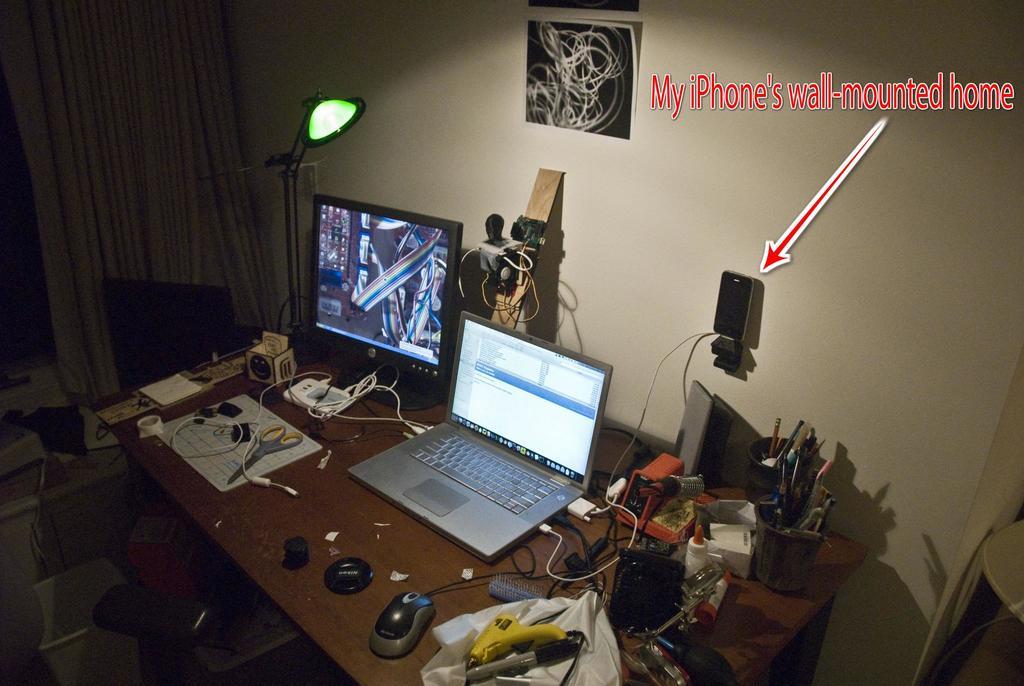What brand phone is mounted on the wall?
Offer a terse response. Iphone. 